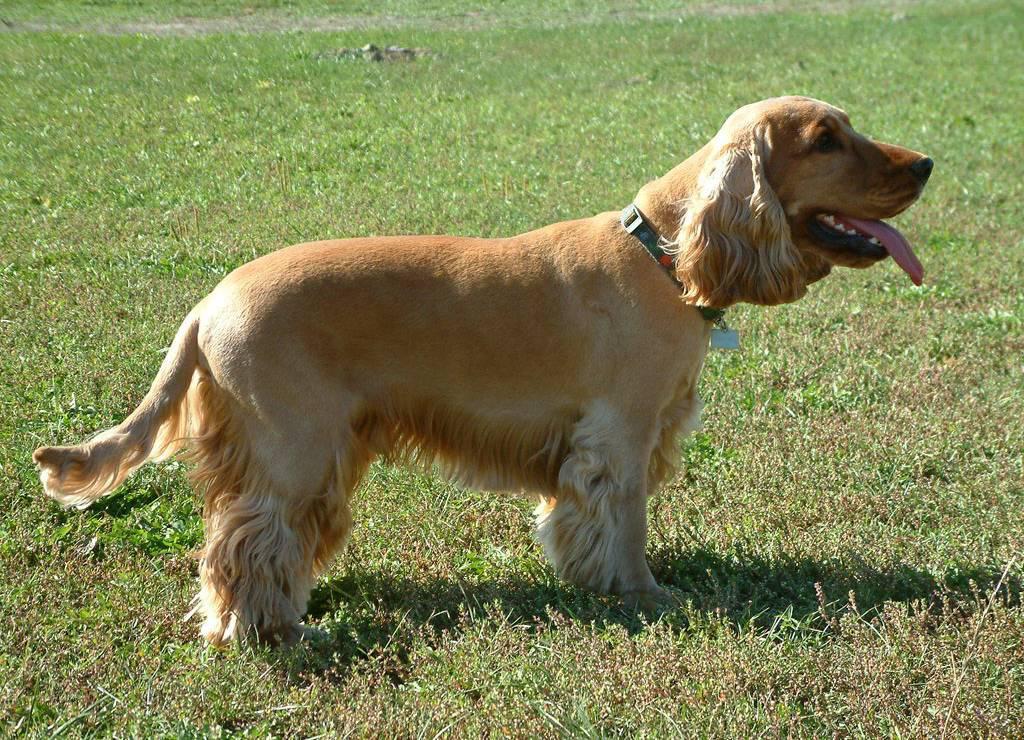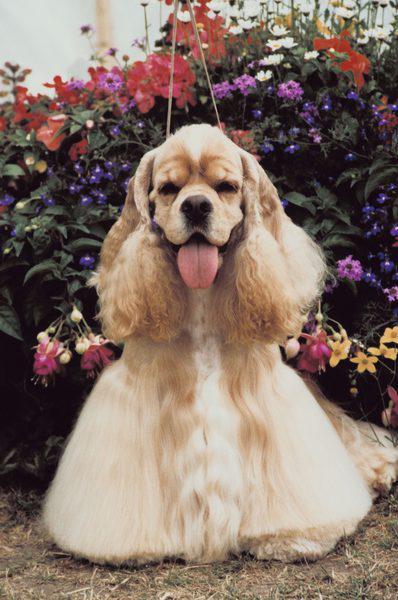The first image is the image on the left, the second image is the image on the right. For the images shown, is this caption "An image shows exactly two red-orange dogs side-by-side." true? Answer yes or no. No. The first image is the image on the left, the second image is the image on the right. Evaluate the accuracy of this statement regarding the images: "All dogs wear a leash or collar.". Is it true? Answer yes or no. Yes. 